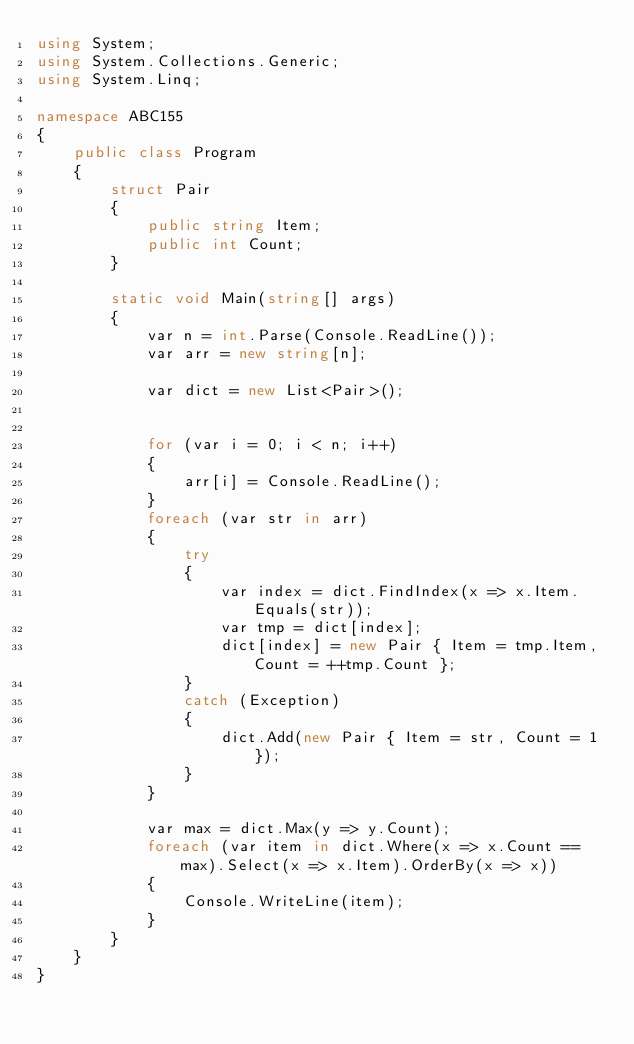<code> <loc_0><loc_0><loc_500><loc_500><_C#_>using System;
using System.Collections.Generic;
using System.Linq;

namespace ABC155
{
    public class Program
    {
        struct Pair
        {
            public string Item;
            public int Count;
        }

        static void Main(string[] args)
        {
            var n = int.Parse(Console.ReadLine());
            var arr = new string[n];

            var dict = new List<Pair>();


            for (var i = 0; i < n; i++)
            {
                arr[i] = Console.ReadLine();
            }
            foreach (var str in arr)
            {
                try
                {
                    var index = dict.FindIndex(x => x.Item.Equals(str));
                    var tmp = dict[index];
                    dict[index] = new Pair { Item = tmp.Item, Count = ++tmp.Count };
                }
                catch (Exception)
                {
                    dict.Add(new Pair { Item = str, Count = 1 });
                }
            }

            var max = dict.Max(y => y.Count);
            foreach (var item in dict.Where(x => x.Count == max).Select(x => x.Item).OrderBy(x => x))
            {
                Console.WriteLine(item);
            }
        }
    }
}
</code> 